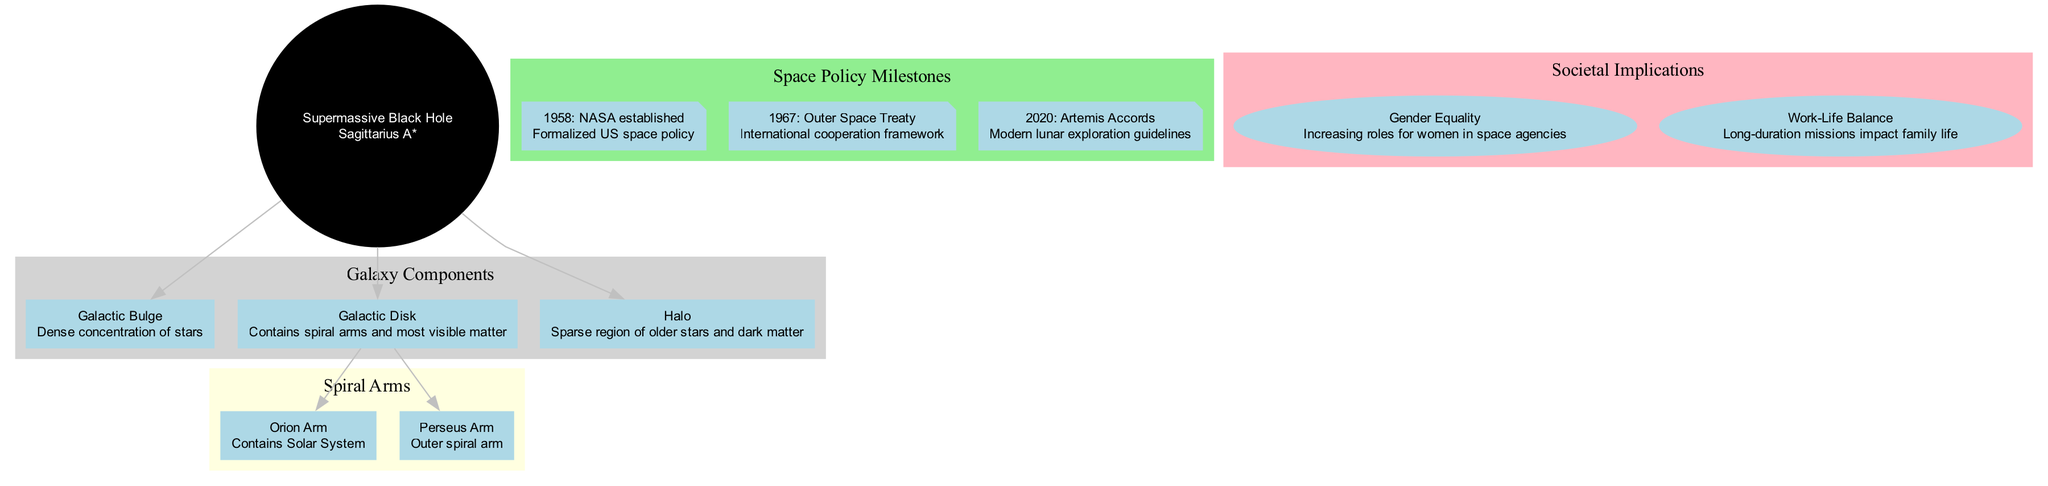What is located at the center of the Milky Way? The diagram indicates that the center of the Milky Way contains a supermassive black hole named Sagittarius A*.
Answer: Sagittarius A* How many spiral arms are there in the Milky Way? The diagram shows two spiral arms: the Orion Arm and the Perseus Arm. Therefore, the total number of spiral arms indicated is two.
Answer: 2 What year was NASA established? The policy milestones section of the diagram specifies that NASA was established in the year 1958.
Answer: 1958 What aspect of societal implications relates to family life? The diagram mentions "Work-Life Balance" as an aspect related to family life, specifically detailing the long-duration missions and their impact.
Answer: Work-Life Balance Which arm contains the Solar System? According to the diagram, the Orion Arm contains the Solar System.
Answer: Orion Arm What is one of the impacts of the Outer Space Treaty? The impact of the Outer Space Treaty, as noted in the diagram, is that it established an international cooperation framework.
Answer: International cooperation framework What color represents the spiral arms in the diagram? The diagram represents the color of the spiral arms as light yellow.
Answer: Light yellow Which policy event occurred in 2020? The diagram states that in 2020, the Artemis Accords were established, providing modern lunar exploration guidelines.
Answer: Artemis Accords What is a key societal implication related to gender in space agencies? The diagram highlights that there is an increasing role for women in space agencies as a societal implication.
Answer: Increasing roles for women in space agencies 